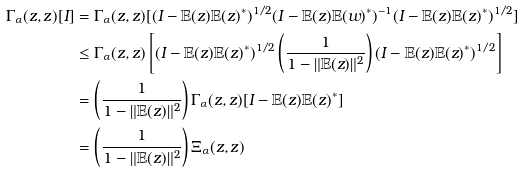<formula> <loc_0><loc_0><loc_500><loc_500>\Gamma _ { \alpha } ( z , z ) [ I ] & = \Gamma _ { \alpha } ( z , z ) [ ( I - { \mathbb { E } } ( z ) { \mathbb { E } } ( z ) ^ { * } ) ^ { 1 / 2 } ( I - { \mathbb { E } } ( z ) { \mathbb { E } } ( w ) ^ { * } ) ^ { - 1 } ( I - { \mathbb { E } } ( z ) { \mathbb { E } } ( z ) ^ { * } ) ^ { 1 / 2 } ] \\ & \leq \Gamma _ { \alpha } ( z , z ) \left [ ( I - { \mathbb { E } } ( z ) { \mathbb { E } } ( z ) ^ { * } ) ^ { 1 / 2 } \left ( \frac { 1 } { 1 - \| { \mathbb { E } } ( z ) \| ^ { 2 } } \right ) ( I - { \mathbb { E } } ( z ) { \mathbb { E } } ( z ) ^ { * } ) ^ { 1 / 2 } \right ] \\ \ & = \left ( \frac { 1 } { 1 - \| { \mathbb { E } } ( z ) \| ^ { 2 } } \right ) \Gamma _ { \alpha } ( z , z ) [ I - { \mathbb { E } } ( z ) { \mathbb { E } } ( z ) ^ { * } ] \\ & = \left ( \frac { 1 } { 1 - \| { \mathbb { E } } ( z ) \| ^ { 2 } } \right ) \Xi _ { \alpha } ( z , z )</formula> 